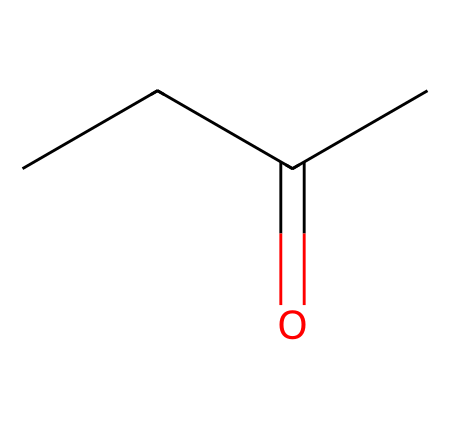How many carbon atoms are in methyl ethyl ketone? In the SMILES notation, "CCC(=O)C" indicates the presence of four carbon atoms. The "C" represents a carbon atom, and there are three "C" in a chain and one at the end before the ketone functional group.
Answer: four What functional group is present in this chemical? The "C(=O)" in the SMILES denotes a carbonyl group, which is characteristic of ketones. Thus, this chemical contains a ketone functional group.
Answer: ketone How many hydrogen atoms are in methyl ethyl ketone? From the structure represented by "CCC(=O)C", we can deduce there are ten hydrogen atoms. Each carbon in an open-chain structure typically bonds with hydrogen. The carbonyl group does not bond with hydrogen in ketones.
Answer: ten What is the molecular formula of methyl ethyl ketone? By analyzing the structure with four carbon (C), eight hydrogen (H), and one oxygen (O) from the carbonyl, the molecular formula can be deduced as C4H8O.
Answer: C4H8O Is methyl ethyl ketone a polar or nonpolar molecule? The presence of the carbonyl group leads to a dipole moment in the molecule, making methyl ethyl ketone polar due to the difference in electronegativity between carbon and oxygen.
Answer: polar How many bonding electrons are in the carbonyl group of this molecule? Each carbon-oxygen double bond in the carbonyl group contributes two bonding electrons, so the carbonyl group (C=O) consists of two bonding electrons.
Answer: two Is methyl ethyl ketone soluble in water? Due to its polar characteristics and the presence of the carbonyl group, methyl ethyl ketone is somewhat soluble in water.
Answer: yes 